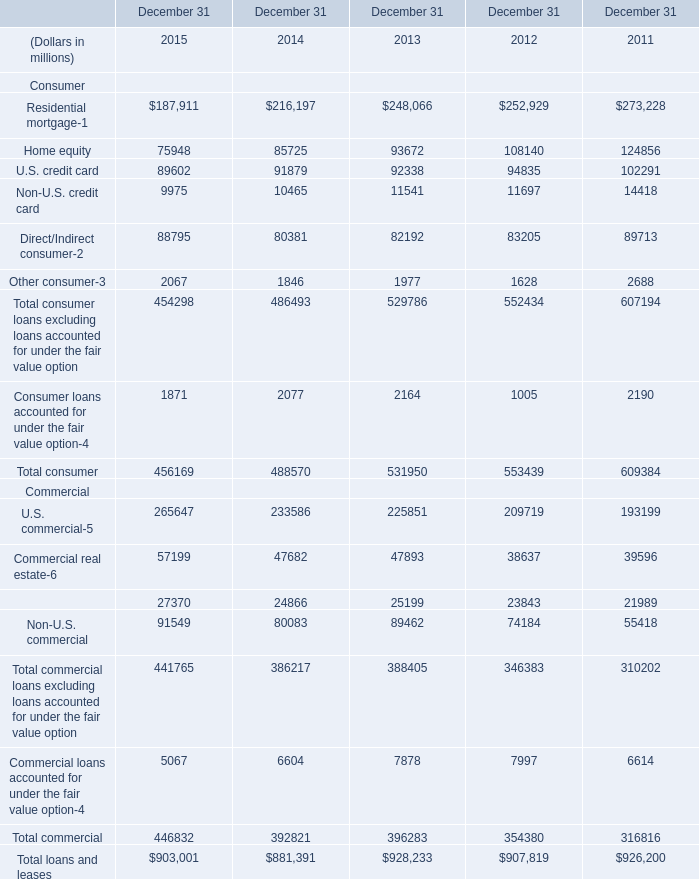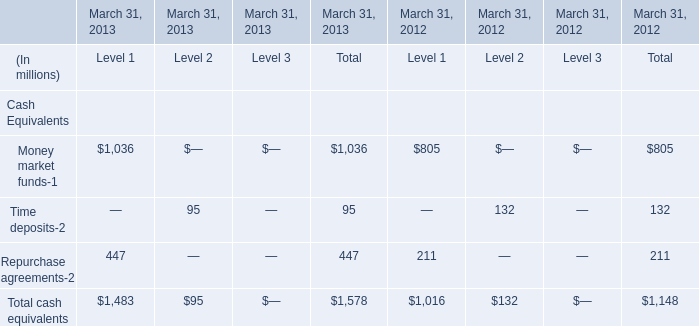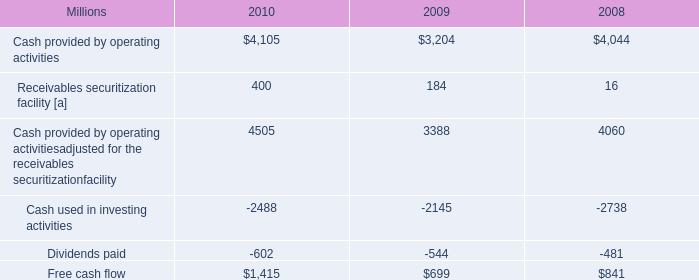what is the annual average dividend paid from 2008-2010 , in millions? 
Computations: (((602 + 544) + 481) / 3)
Answer: 542.33333. 